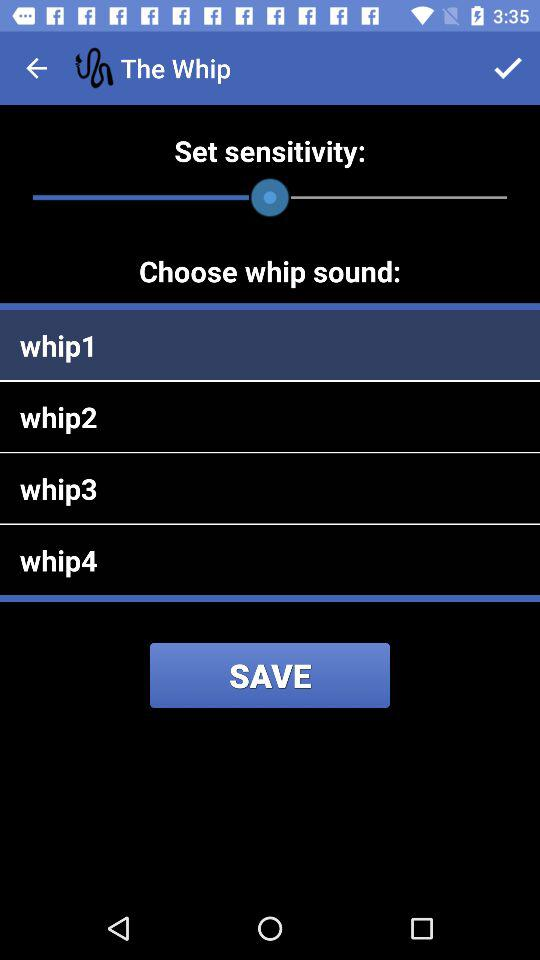How many whip sounds are available?
Answer the question using a single word or phrase. 4 